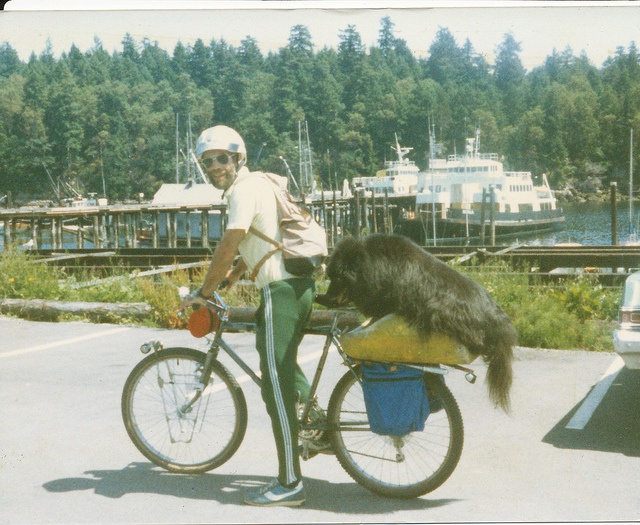Describe the objects in this image and their specific colors. I can see bicycle in black, lightgray, gray, darkgreen, and darkgray tones, people in black, beige, darkgreen, and darkgray tones, dog in black, darkgreen, and olive tones, boat in black, beige, darkgray, and gray tones, and handbag in black, teal, and gray tones in this image. 